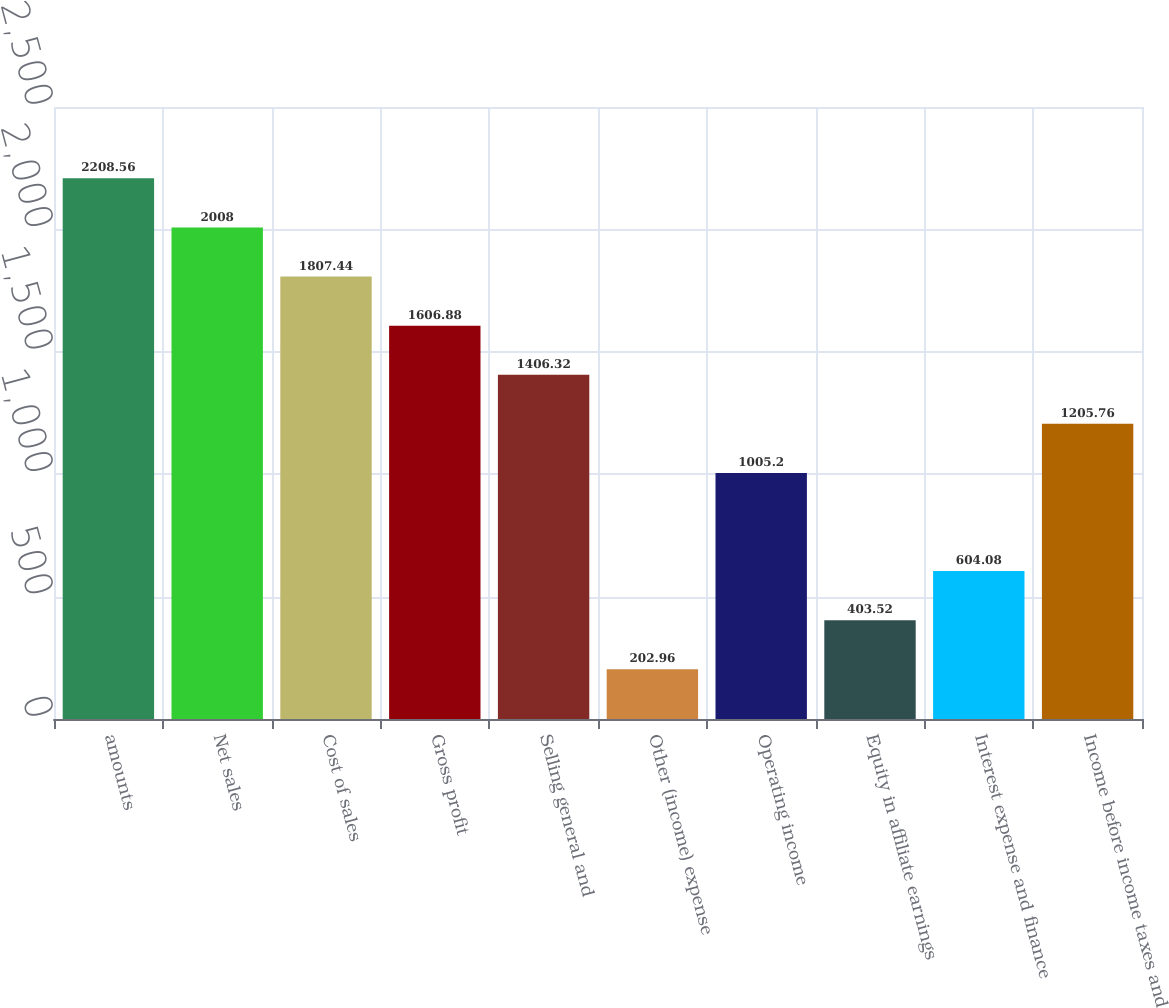Convert chart. <chart><loc_0><loc_0><loc_500><loc_500><bar_chart><fcel>amounts<fcel>Net sales<fcel>Cost of sales<fcel>Gross profit<fcel>Selling general and<fcel>Other (income) expense<fcel>Operating income<fcel>Equity in affiliate earnings<fcel>Interest expense and finance<fcel>Income before income taxes and<nl><fcel>2208.56<fcel>2008<fcel>1807.44<fcel>1606.88<fcel>1406.32<fcel>202.96<fcel>1005.2<fcel>403.52<fcel>604.08<fcel>1205.76<nl></chart> 